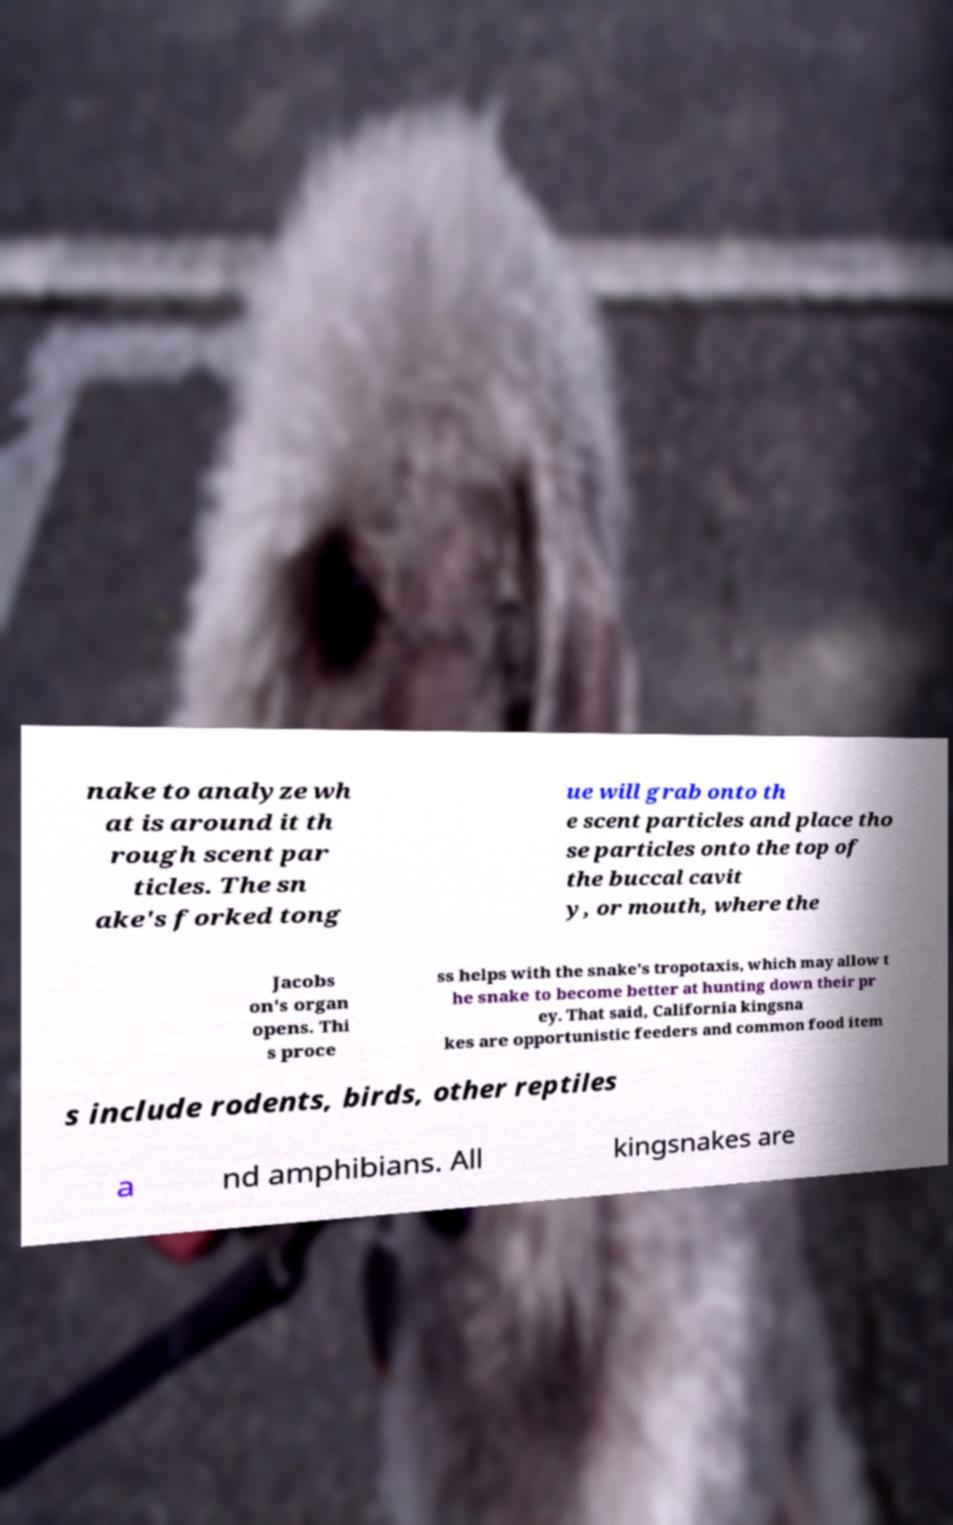Please read and relay the text visible in this image. What does it say? nake to analyze wh at is around it th rough scent par ticles. The sn ake's forked tong ue will grab onto th e scent particles and place tho se particles onto the top of the buccal cavit y, or mouth, where the Jacobs on's organ opens. Thi s proce ss helps with the snake's tropotaxis, which may allow t he snake to become better at hunting down their pr ey. That said, California kingsna kes are opportunistic feeders and common food item s include rodents, birds, other reptiles a nd amphibians. All kingsnakes are 